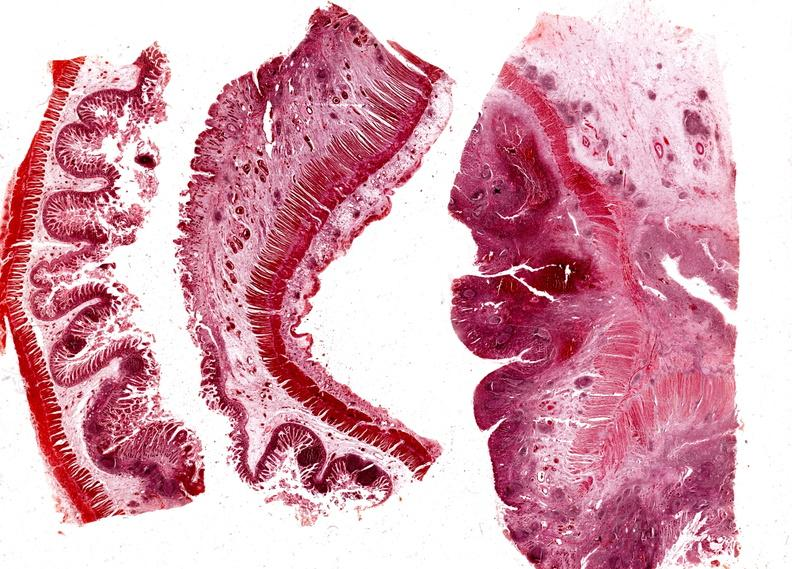does this image show colon, regional enteritis?
Answer the question using a single word or phrase. Yes 